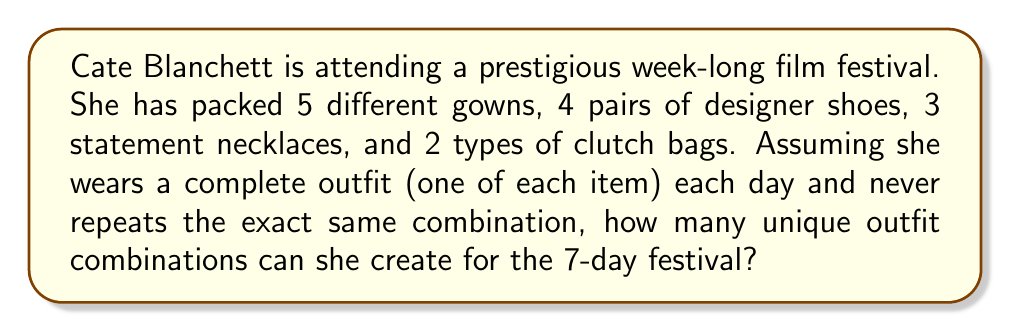Provide a solution to this math problem. Let's approach this step-by-step:

1) First, we need to understand that this is a multiplication principle problem in combinatorics. We're choosing one item from each category to create a complete outfit.

2) For each outfit, Cate needs to choose:
   - 1 gown out of 5
   - 1 pair of shoes out of 4
   - 1 necklace out of 3
   - 1 clutch bag out of 2

3) According to the multiplication principle, if we have a series of choices where:
   - We have $m$ ways of doing something,
   - $n$ ways of doing another thing,
   - $p$ ways of doing a third thing, and so on,
   Then the total number of ways to do all of these things is $m \times n \times p \times ...$

4) In this case, we have:
   $5$ ways to choose a gown
   $4$ ways to choose shoes
   $3$ ways to choose a necklace
   $2$ ways to choose a clutch bag

5) Therefore, the total number of unique outfit combinations is:

   $5 \times 4 \times 3 \times 2 = 120$

6) This means Cate can create 120 unique outfits, which is more than enough for the 7-day festival without repeating any combination.
Answer: 120 unique outfit combinations 